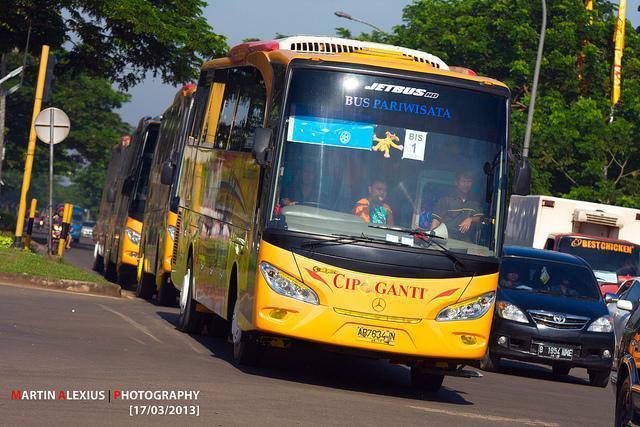How many buses are in a row?
Give a very brief answer. 3. How many cars are in the photo?
Give a very brief answer. 2. How many buses can you see?
Give a very brief answer. 3. 